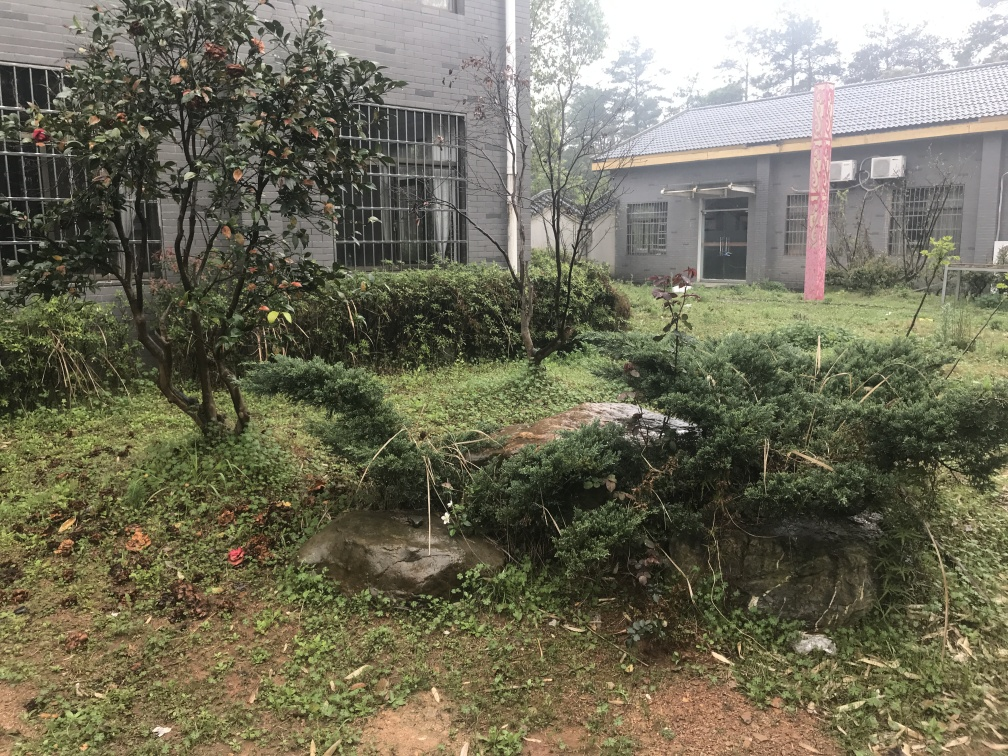What can you infer about the weather and the time of year from this image? The weather appears overcast, as indicated by the diffused lighting and the lack of shadows. The greenery suggests it's either spring or summer, when plants would be lush. However, the ground looks damp and there's no visible snow, so it's likely not winter. The wear on the plants and leaves scattered on the ground could also imply that the photo was taken during late autumn. 